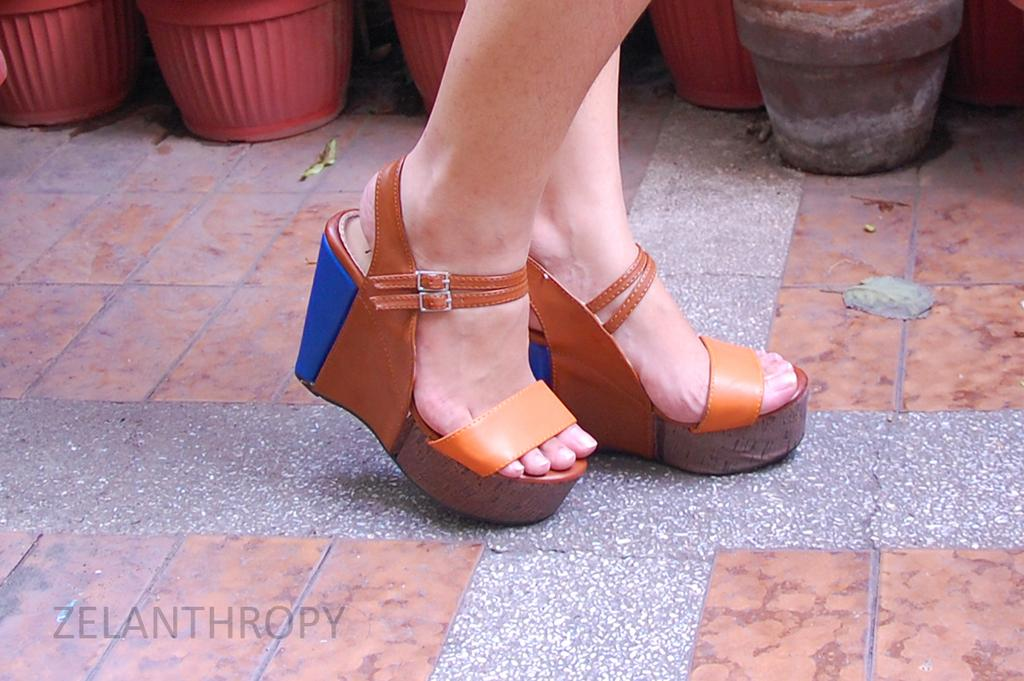What type of footwear are the women wearing in the image? The women are wearing heels in the image. What is the surface the women are standing on? The women are standing on the ground. How many flower pots can be seen in the background of the image? There are six flower pots in the background of the image. Is there any branding or symbol present in the image? Yes, there is a logo in the image. What type of apple is being shared between the two brothers in the image? There are no apples or brothers present in the image; it features women wearing heels and flower pots in the background. How does the cough of the person in the image affect their ability to stand on the ground? There is no person coughing in the image; the women are standing on the ground without any apparent difficulty. 